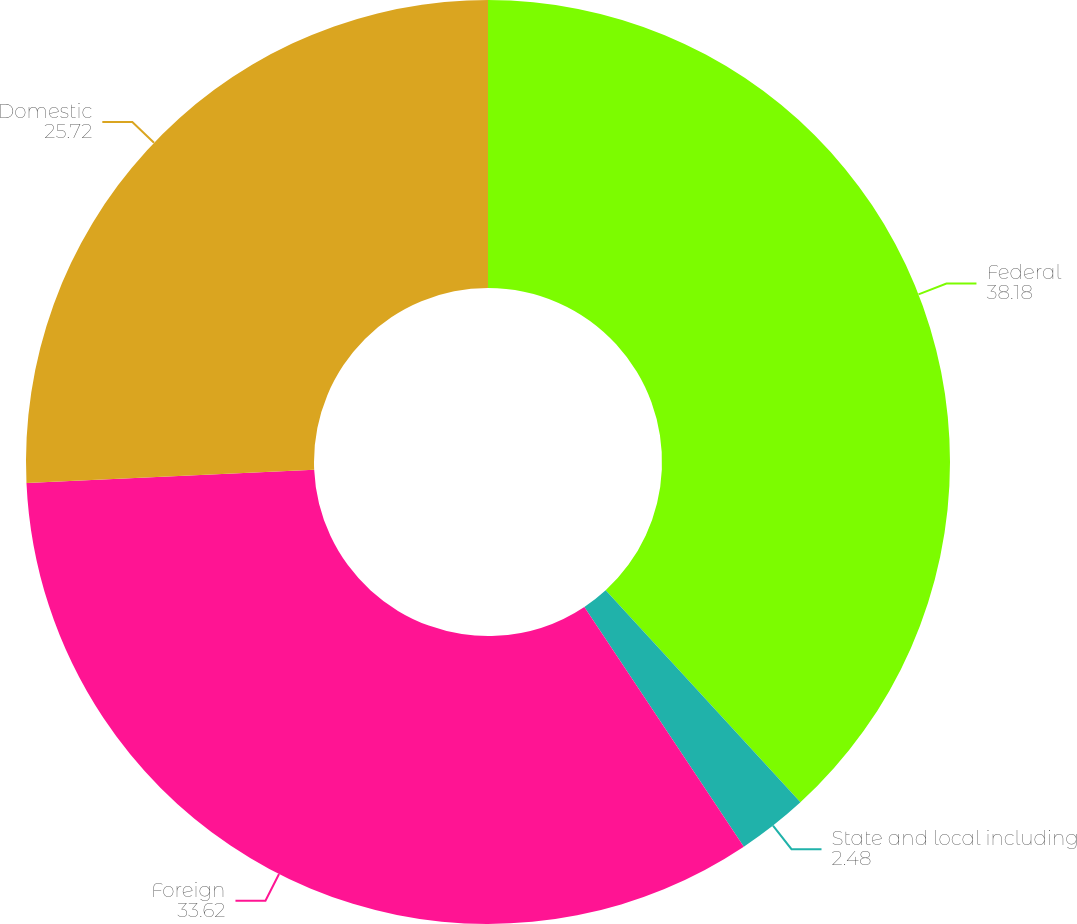Convert chart. <chart><loc_0><loc_0><loc_500><loc_500><pie_chart><fcel>Federal<fcel>State and local including<fcel>Foreign<fcel>Domestic<nl><fcel>38.18%<fcel>2.48%<fcel>33.62%<fcel>25.72%<nl></chart> 